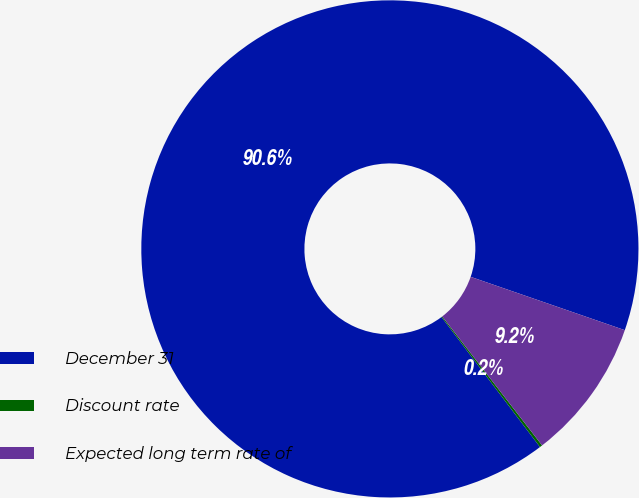<chart> <loc_0><loc_0><loc_500><loc_500><pie_chart><fcel>December 31<fcel>Discount rate<fcel>Expected long term rate of<nl><fcel>90.62%<fcel>0.17%<fcel>9.21%<nl></chart> 